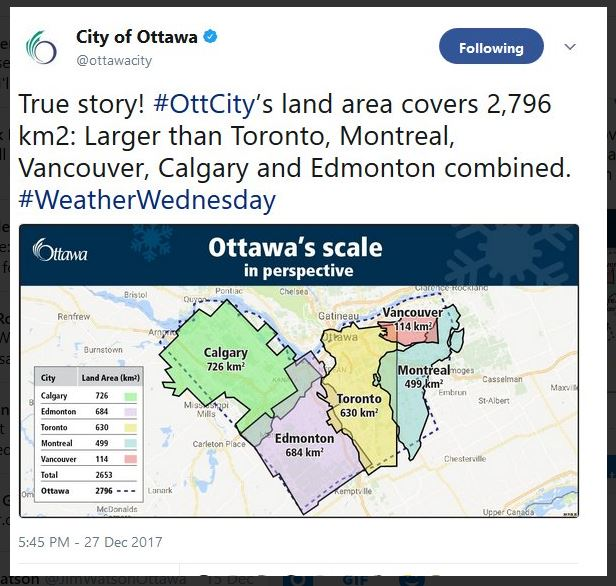How might Ottawa's larger land area affect its environmental policies? Ottawa’s expansive land area allows for diverse environmental initiatives. The city can allocate more space for parks, forests, and conservation areas, promoting biodiversity. Large green spaces can also serve as carbon sinks, helping the city’s efforts to combat climate change. Furthermore, Ottawa can pioneer urban agriculture projects and eco-friendly zones, reducing its carbon footprint. However, managing such a vast area requires robust policies to protect these spaces from urban sprawl, ensuring sustainable development while preserving natural habitats. 